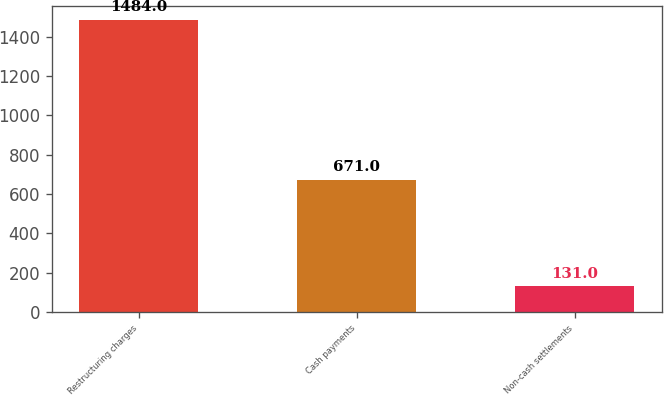Convert chart. <chart><loc_0><loc_0><loc_500><loc_500><bar_chart><fcel>Restructuring charges<fcel>Cash payments<fcel>Non-cash settlements<nl><fcel>1484<fcel>671<fcel>131<nl></chart> 